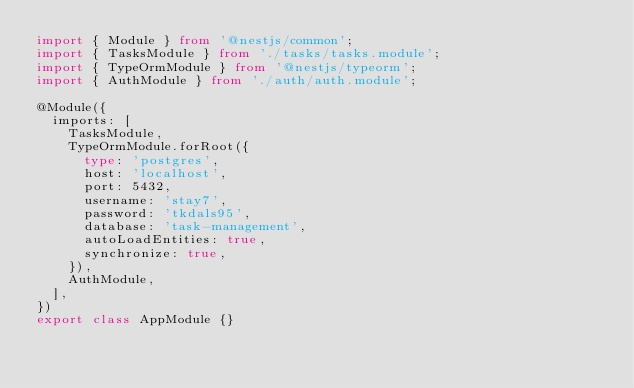<code> <loc_0><loc_0><loc_500><loc_500><_TypeScript_>import { Module } from '@nestjs/common';
import { TasksModule } from './tasks/tasks.module';
import { TypeOrmModule } from '@nestjs/typeorm';
import { AuthModule } from './auth/auth.module';

@Module({
  imports: [
    TasksModule,
    TypeOrmModule.forRoot({
      type: 'postgres',
      host: 'localhost',
      port: 5432,
      username: 'stay7',
      password: 'tkdals95',
      database: 'task-management',
      autoLoadEntities: true,
      synchronize: true,
    }),
    AuthModule,
  ],
})
export class AppModule {}
</code> 